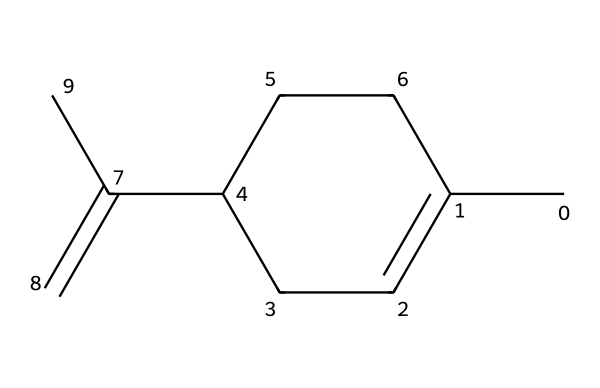What is the main functional group present in limonene? The provided SMILES structure indicates that it contains a double bond (C=C) as part of its cyclic structure. The presence of the double bond characterizes it as an alkene, which is the main functional group present.
Answer: alkene How many carbon atoms are in limonene? By analyzing the SMILES notation, we can count the carbon atoms represented by 'C'. There are a total of 10 carbon atoms in the structure of limonene.
Answer: 10 What is the molecular formula of limonene? To derive the molecular formula, we summarize the counted atoms from the SMILES notation: 10 carbon atoms and 16 hydrogen atoms, giving us C10H16.
Answer: C10H16 What type of odors does limonene commonly exhibit? Limonene is known for its characteristic citrus scent, which is often associated with oranges and lemons.
Answer: citrus What is the boiling point range of limonene? Limonene typically boils between 176 to 177 degrees Celsius, as it’s a well-documented terpene with defined physical properties.
Answer: 176-177 degrees Celsius How does the structure of limonene contribute to its fragrance? The presence of the cyclic structure and double bond allows for specific interactions with olfactory receptors, enhancing its characteristic citrus fragrance known for its uplifting properties.
Answer: cyclic structure and double bond Can limonene be used as a natural solvent? Yes, limonene is often utilized as a natural solvent due to its ability to dissolve oils and its pleasant citrus aroma, making it more favorable in many applications compared to synthetic solvents.
Answer: yes 